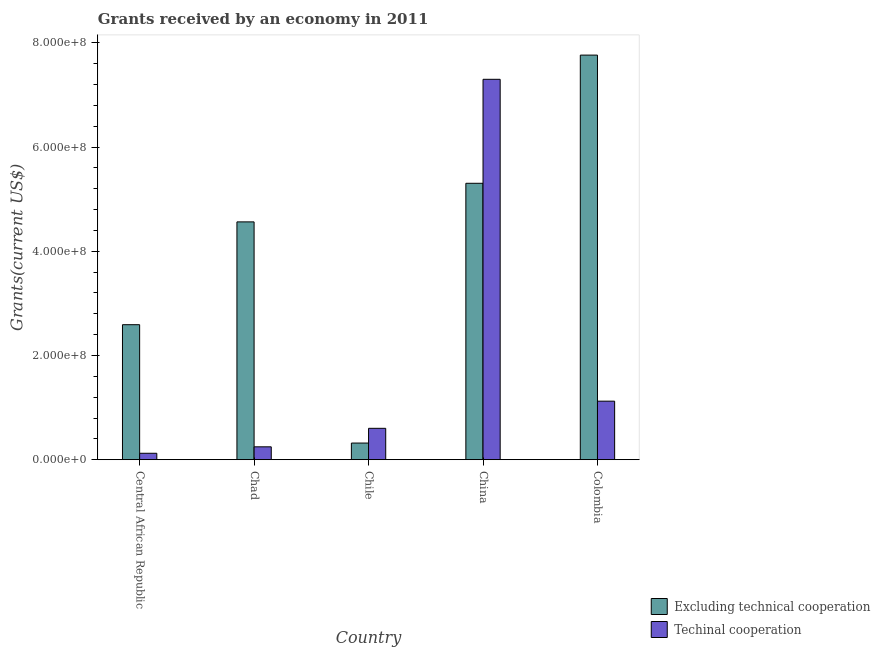How many different coloured bars are there?
Provide a succinct answer. 2. Are the number of bars per tick equal to the number of legend labels?
Offer a very short reply. Yes. Are the number of bars on each tick of the X-axis equal?
Your answer should be compact. Yes. What is the label of the 1st group of bars from the left?
Give a very brief answer. Central African Republic. In how many cases, is the number of bars for a given country not equal to the number of legend labels?
Provide a succinct answer. 0. What is the amount of grants received(including technical cooperation) in Central African Republic?
Your answer should be very brief. 1.23e+07. Across all countries, what is the maximum amount of grants received(including technical cooperation)?
Your answer should be very brief. 7.30e+08. Across all countries, what is the minimum amount of grants received(including technical cooperation)?
Your answer should be very brief. 1.23e+07. In which country was the amount of grants received(excluding technical cooperation) maximum?
Provide a short and direct response. Colombia. In which country was the amount of grants received(excluding technical cooperation) minimum?
Offer a very short reply. Chile. What is the total amount of grants received(including technical cooperation) in the graph?
Offer a very short reply. 9.40e+08. What is the difference between the amount of grants received(excluding technical cooperation) in Chile and that in China?
Your response must be concise. -4.98e+08. What is the difference between the amount of grants received(excluding technical cooperation) in Central African Republic and the amount of grants received(including technical cooperation) in Colombia?
Make the answer very short. 1.47e+08. What is the average amount of grants received(excluding technical cooperation) per country?
Provide a succinct answer. 4.11e+08. What is the difference between the amount of grants received(excluding technical cooperation) and amount of grants received(including technical cooperation) in Chad?
Offer a very short reply. 4.32e+08. What is the ratio of the amount of grants received(excluding technical cooperation) in Chile to that in China?
Make the answer very short. 0.06. Is the amount of grants received(excluding technical cooperation) in Central African Republic less than that in Colombia?
Offer a terse response. Yes. What is the difference between the highest and the second highest amount of grants received(including technical cooperation)?
Offer a very short reply. 6.18e+08. What is the difference between the highest and the lowest amount of grants received(excluding technical cooperation)?
Your answer should be compact. 7.45e+08. In how many countries, is the amount of grants received(including technical cooperation) greater than the average amount of grants received(including technical cooperation) taken over all countries?
Your response must be concise. 1. What does the 1st bar from the left in Chile represents?
Give a very brief answer. Excluding technical cooperation. What does the 1st bar from the right in Chad represents?
Your answer should be compact. Techinal cooperation. How many bars are there?
Provide a succinct answer. 10. What is the difference between two consecutive major ticks on the Y-axis?
Provide a short and direct response. 2.00e+08. Are the values on the major ticks of Y-axis written in scientific E-notation?
Provide a succinct answer. Yes. Does the graph contain any zero values?
Keep it short and to the point. No. Does the graph contain grids?
Provide a succinct answer. No. What is the title of the graph?
Offer a terse response. Grants received by an economy in 2011. Does "Short-term debt" appear as one of the legend labels in the graph?
Your answer should be very brief. No. What is the label or title of the Y-axis?
Ensure brevity in your answer.  Grants(current US$). What is the Grants(current US$) of Excluding technical cooperation in Central African Republic?
Make the answer very short. 2.59e+08. What is the Grants(current US$) in Techinal cooperation in Central African Republic?
Your answer should be very brief. 1.23e+07. What is the Grants(current US$) of Excluding technical cooperation in Chad?
Give a very brief answer. 4.56e+08. What is the Grants(current US$) of Techinal cooperation in Chad?
Provide a succinct answer. 2.47e+07. What is the Grants(current US$) of Excluding technical cooperation in Chile?
Give a very brief answer. 3.20e+07. What is the Grants(current US$) in Techinal cooperation in Chile?
Provide a succinct answer. 6.02e+07. What is the Grants(current US$) of Excluding technical cooperation in China?
Ensure brevity in your answer.  5.30e+08. What is the Grants(current US$) of Techinal cooperation in China?
Provide a succinct answer. 7.30e+08. What is the Grants(current US$) in Excluding technical cooperation in Colombia?
Provide a succinct answer. 7.76e+08. What is the Grants(current US$) in Techinal cooperation in Colombia?
Provide a succinct answer. 1.12e+08. Across all countries, what is the maximum Grants(current US$) in Excluding technical cooperation?
Offer a terse response. 7.76e+08. Across all countries, what is the maximum Grants(current US$) in Techinal cooperation?
Your response must be concise. 7.30e+08. Across all countries, what is the minimum Grants(current US$) in Excluding technical cooperation?
Offer a very short reply. 3.20e+07. Across all countries, what is the minimum Grants(current US$) of Techinal cooperation?
Provide a succinct answer. 1.23e+07. What is the total Grants(current US$) of Excluding technical cooperation in the graph?
Give a very brief answer. 2.05e+09. What is the total Grants(current US$) of Techinal cooperation in the graph?
Your answer should be compact. 9.40e+08. What is the difference between the Grants(current US$) in Excluding technical cooperation in Central African Republic and that in Chad?
Make the answer very short. -1.97e+08. What is the difference between the Grants(current US$) in Techinal cooperation in Central African Republic and that in Chad?
Make the answer very short. -1.24e+07. What is the difference between the Grants(current US$) of Excluding technical cooperation in Central African Republic and that in Chile?
Your answer should be compact. 2.27e+08. What is the difference between the Grants(current US$) in Techinal cooperation in Central African Republic and that in Chile?
Offer a very short reply. -4.79e+07. What is the difference between the Grants(current US$) of Excluding technical cooperation in Central African Republic and that in China?
Keep it short and to the point. -2.71e+08. What is the difference between the Grants(current US$) of Techinal cooperation in Central African Republic and that in China?
Your response must be concise. -7.18e+08. What is the difference between the Grants(current US$) of Excluding technical cooperation in Central African Republic and that in Colombia?
Make the answer very short. -5.17e+08. What is the difference between the Grants(current US$) in Techinal cooperation in Central African Republic and that in Colombia?
Provide a short and direct response. -1.00e+08. What is the difference between the Grants(current US$) in Excluding technical cooperation in Chad and that in Chile?
Keep it short and to the point. 4.24e+08. What is the difference between the Grants(current US$) in Techinal cooperation in Chad and that in Chile?
Make the answer very short. -3.55e+07. What is the difference between the Grants(current US$) in Excluding technical cooperation in Chad and that in China?
Your answer should be compact. -7.41e+07. What is the difference between the Grants(current US$) in Techinal cooperation in Chad and that in China?
Give a very brief answer. -7.05e+08. What is the difference between the Grants(current US$) of Excluding technical cooperation in Chad and that in Colombia?
Provide a succinct answer. -3.20e+08. What is the difference between the Grants(current US$) of Techinal cooperation in Chad and that in Colombia?
Give a very brief answer. -8.76e+07. What is the difference between the Grants(current US$) of Excluding technical cooperation in Chile and that in China?
Your answer should be compact. -4.98e+08. What is the difference between the Grants(current US$) in Techinal cooperation in Chile and that in China?
Provide a short and direct response. -6.70e+08. What is the difference between the Grants(current US$) of Excluding technical cooperation in Chile and that in Colombia?
Ensure brevity in your answer.  -7.45e+08. What is the difference between the Grants(current US$) of Techinal cooperation in Chile and that in Colombia?
Your response must be concise. -5.21e+07. What is the difference between the Grants(current US$) of Excluding technical cooperation in China and that in Colombia?
Make the answer very short. -2.46e+08. What is the difference between the Grants(current US$) of Techinal cooperation in China and that in Colombia?
Make the answer very short. 6.18e+08. What is the difference between the Grants(current US$) of Excluding technical cooperation in Central African Republic and the Grants(current US$) of Techinal cooperation in Chad?
Offer a terse response. 2.34e+08. What is the difference between the Grants(current US$) in Excluding technical cooperation in Central African Republic and the Grants(current US$) in Techinal cooperation in Chile?
Make the answer very short. 1.99e+08. What is the difference between the Grants(current US$) in Excluding technical cooperation in Central African Republic and the Grants(current US$) in Techinal cooperation in China?
Ensure brevity in your answer.  -4.71e+08. What is the difference between the Grants(current US$) in Excluding technical cooperation in Central African Republic and the Grants(current US$) in Techinal cooperation in Colombia?
Offer a terse response. 1.47e+08. What is the difference between the Grants(current US$) in Excluding technical cooperation in Chad and the Grants(current US$) in Techinal cooperation in Chile?
Your answer should be compact. 3.96e+08. What is the difference between the Grants(current US$) in Excluding technical cooperation in Chad and the Grants(current US$) in Techinal cooperation in China?
Give a very brief answer. -2.74e+08. What is the difference between the Grants(current US$) in Excluding technical cooperation in Chad and the Grants(current US$) in Techinal cooperation in Colombia?
Make the answer very short. 3.44e+08. What is the difference between the Grants(current US$) in Excluding technical cooperation in Chile and the Grants(current US$) in Techinal cooperation in China?
Offer a terse response. -6.98e+08. What is the difference between the Grants(current US$) of Excluding technical cooperation in Chile and the Grants(current US$) of Techinal cooperation in Colombia?
Give a very brief answer. -8.04e+07. What is the difference between the Grants(current US$) of Excluding technical cooperation in China and the Grants(current US$) of Techinal cooperation in Colombia?
Give a very brief answer. 4.18e+08. What is the average Grants(current US$) in Excluding technical cooperation per country?
Ensure brevity in your answer.  4.11e+08. What is the average Grants(current US$) in Techinal cooperation per country?
Provide a succinct answer. 1.88e+08. What is the difference between the Grants(current US$) in Excluding technical cooperation and Grants(current US$) in Techinal cooperation in Central African Republic?
Offer a terse response. 2.47e+08. What is the difference between the Grants(current US$) of Excluding technical cooperation and Grants(current US$) of Techinal cooperation in Chad?
Ensure brevity in your answer.  4.32e+08. What is the difference between the Grants(current US$) of Excluding technical cooperation and Grants(current US$) of Techinal cooperation in Chile?
Provide a short and direct response. -2.83e+07. What is the difference between the Grants(current US$) of Excluding technical cooperation and Grants(current US$) of Techinal cooperation in China?
Ensure brevity in your answer.  -2.00e+08. What is the difference between the Grants(current US$) of Excluding technical cooperation and Grants(current US$) of Techinal cooperation in Colombia?
Your answer should be compact. 6.64e+08. What is the ratio of the Grants(current US$) in Excluding technical cooperation in Central African Republic to that in Chad?
Keep it short and to the point. 0.57. What is the ratio of the Grants(current US$) in Techinal cooperation in Central African Republic to that in Chad?
Make the answer very short. 0.5. What is the ratio of the Grants(current US$) in Excluding technical cooperation in Central African Republic to that in Chile?
Make the answer very short. 8.11. What is the ratio of the Grants(current US$) of Techinal cooperation in Central African Republic to that in Chile?
Keep it short and to the point. 0.2. What is the ratio of the Grants(current US$) in Excluding technical cooperation in Central African Republic to that in China?
Offer a very short reply. 0.49. What is the ratio of the Grants(current US$) of Techinal cooperation in Central African Republic to that in China?
Your answer should be very brief. 0.02. What is the ratio of the Grants(current US$) of Excluding technical cooperation in Central African Republic to that in Colombia?
Offer a terse response. 0.33. What is the ratio of the Grants(current US$) in Techinal cooperation in Central African Republic to that in Colombia?
Provide a succinct answer. 0.11. What is the ratio of the Grants(current US$) in Excluding technical cooperation in Chad to that in Chile?
Provide a succinct answer. 14.28. What is the ratio of the Grants(current US$) in Techinal cooperation in Chad to that in Chile?
Provide a short and direct response. 0.41. What is the ratio of the Grants(current US$) of Excluding technical cooperation in Chad to that in China?
Provide a succinct answer. 0.86. What is the ratio of the Grants(current US$) in Techinal cooperation in Chad to that in China?
Ensure brevity in your answer.  0.03. What is the ratio of the Grants(current US$) of Excluding technical cooperation in Chad to that in Colombia?
Keep it short and to the point. 0.59. What is the ratio of the Grants(current US$) in Techinal cooperation in Chad to that in Colombia?
Make the answer very short. 0.22. What is the ratio of the Grants(current US$) in Excluding technical cooperation in Chile to that in China?
Offer a very short reply. 0.06. What is the ratio of the Grants(current US$) of Techinal cooperation in Chile to that in China?
Ensure brevity in your answer.  0.08. What is the ratio of the Grants(current US$) in Excluding technical cooperation in Chile to that in Colombia?
Give a very brief answer. 0.04. What is the ratio of the Grants(current US$) in Techinal cooperation in Chile to that in Colombia?
Offer a very short reply. 0.54. What is the ratio of the Grants(current US$) in Excluding technical cooperation in China to that in Colombia?
Your answer should be very brief. 0.68. What is the ratio of the Grants(current US$) in Techinal cooperation in China to that in Colombia?
Offer a terse response. 6.5. What is the difference between the highest and the second highest Grants(current US$) of Excluding technical cooperation?
Your response must be concise. 2.46e+08. What is the difference between the highest and the second highest Grants(current US$) in Techinal cooperation?
Give a very brief answer. 6.18e+08. What is the difference between the highest and the lowest Grants(current US$) of Excluding technical cooperation?
Your answer should be compact. 7.45e+08. What is the difference between the highest and the lowest Grants(current US$) of Techinal cooperation?
Provide a succinct answer. 7.18e+08. 